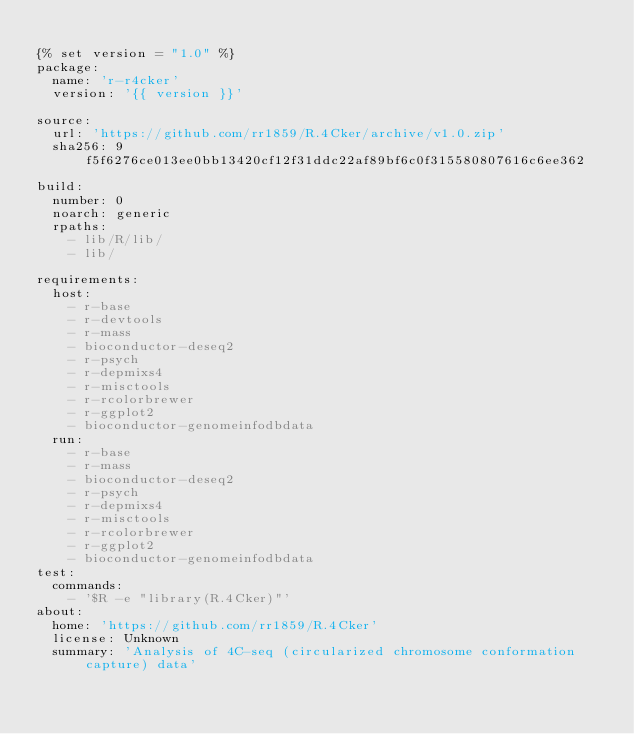Convert code to text. <code><loc_0><loc_0><loc_500><loc_500><_YAML_>
{% set version = "1.0" %}
package:
  name: 'r-r4cker'
  version: '{{ version }}'

source:
  url: 'https://github.com/rr1859/R.4Cker/archive/v1.0.zip'
  sha256: 9f5f6276ce013ee0bb13420cf12f31ddc22af89bf6c0f315580807616c6ee362

build:
  number: 0
  noarch: generic
  rpaths:
    - lib/R/lib/
    - lib/

requirements:
  host:
    - r-base
    - r-devtools
    - r-mass
    - bioconductor-deseq2
    - r-psych
    - r-depmixs4
    - r-misctools
    - r-rcolorbrewer
    - r-ggplot2
    - bioconductor-genomeinfodbdata 
  run:
    - r-base
    - r-mass
    - bioconductor-deseq2
    - r-psych
    - r-depmixs4
    - r-misctools
    - r-rcolorbrewer
    - r-ggplot2
    - bioconductor-genomeinfodbdata 
test:
  commands:
    - '$R -e "library(R.4Cker)"'
about:
  home: 'https://github.com/rr1859/R.4Cker'
  license: Unknown
  summary: 'Analysis of 4C-seq (circularized chromosome conformation capture) data'
</code> 